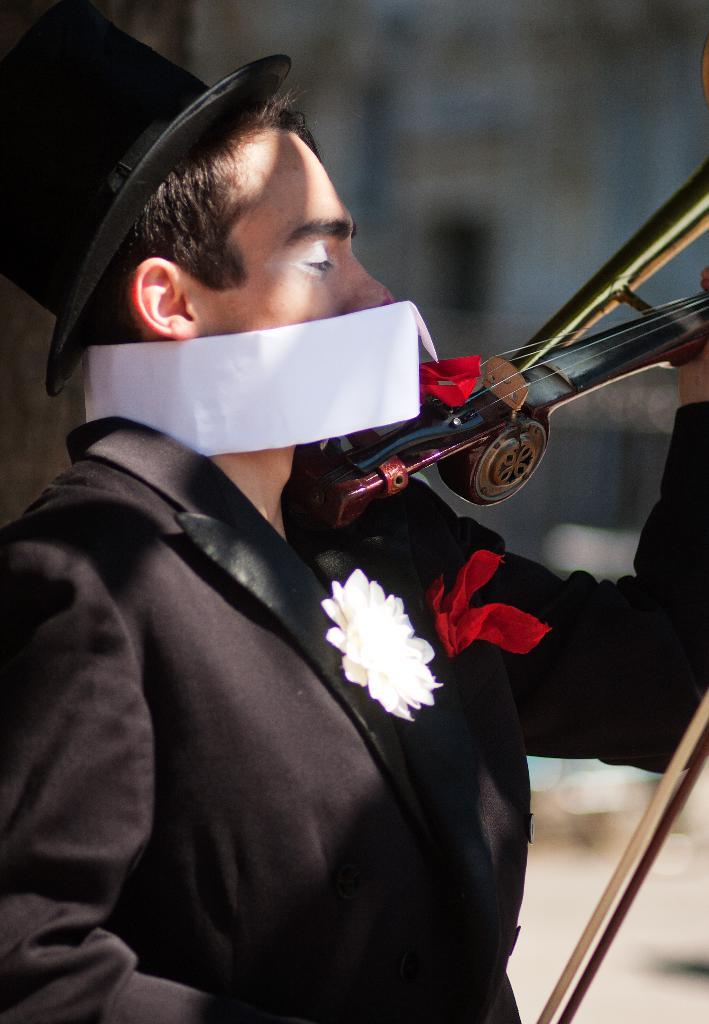What is the main subject of the image? The main subject of the image is a man. What is the man wearing in the image? The man is wearing a suit and a hat in the image. What activity is the man engaged in? The man is playing the violin in the image. What direction is the man's wish being granted from in the image? There is no indication in the image of a wish being granted or a specific direction from which it is being granted. 